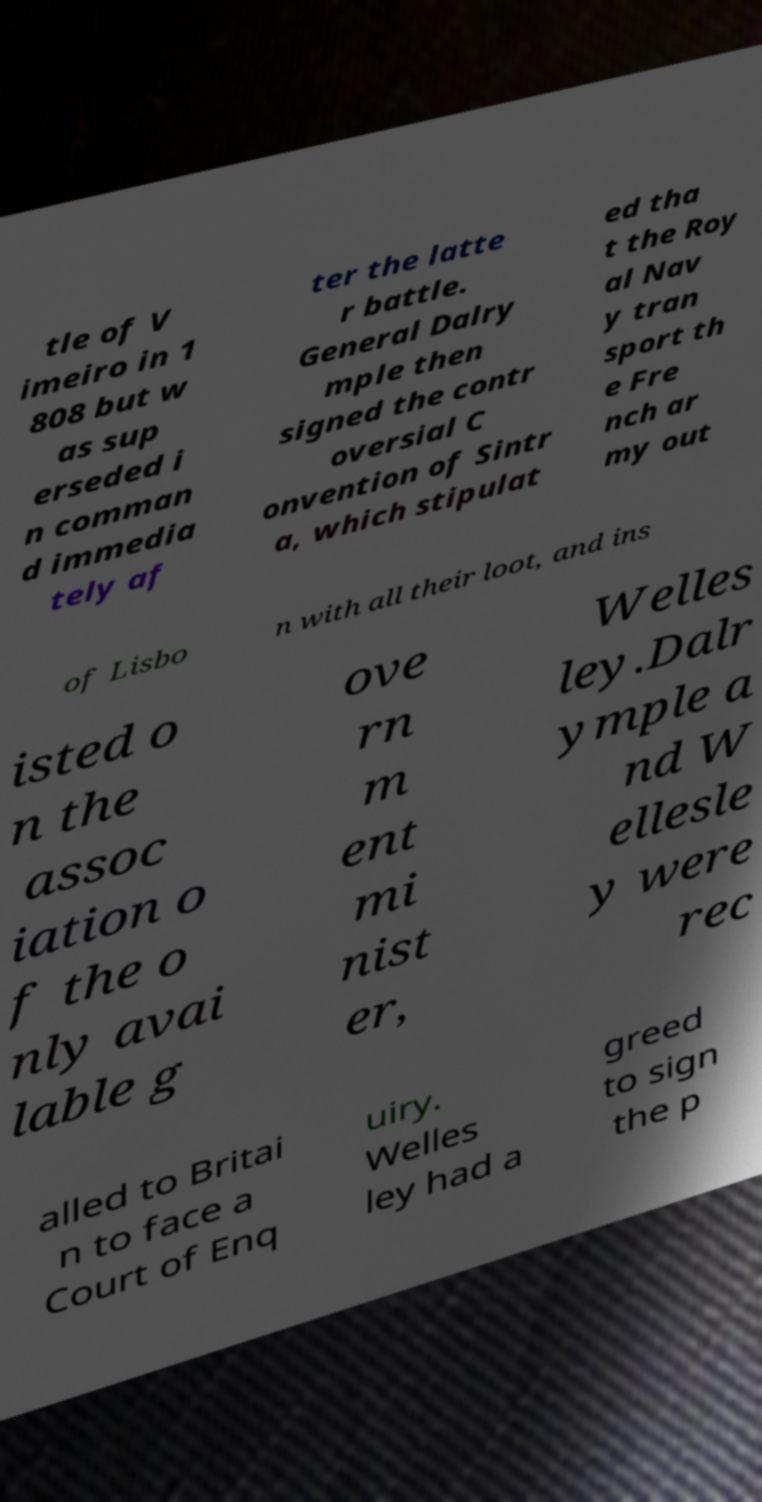Can you read and provide the text displayed in the image?This photo seems to have some interesting text. Can you extract and type it out for me? tle of V imeiro in 1 808 but w as sup erseded i n comman d immedia tely af ter the latte r battle. General Dalry mple then signed the contr oversial C onvention of Sintr a, which stipulat ed tha t the Roy al Nav y tran sport th e Fre nch ar my out of Lisbo n with all their loot, and ins isted o n the assoc iation o f the o nly avai lable g ove rn m ent mi nist er, Welles ley.Dalr ymple a nd W ellesle y were rec alled to Britai n to face a Court of Enq uiry. Welles ley had a greed to sign the p 